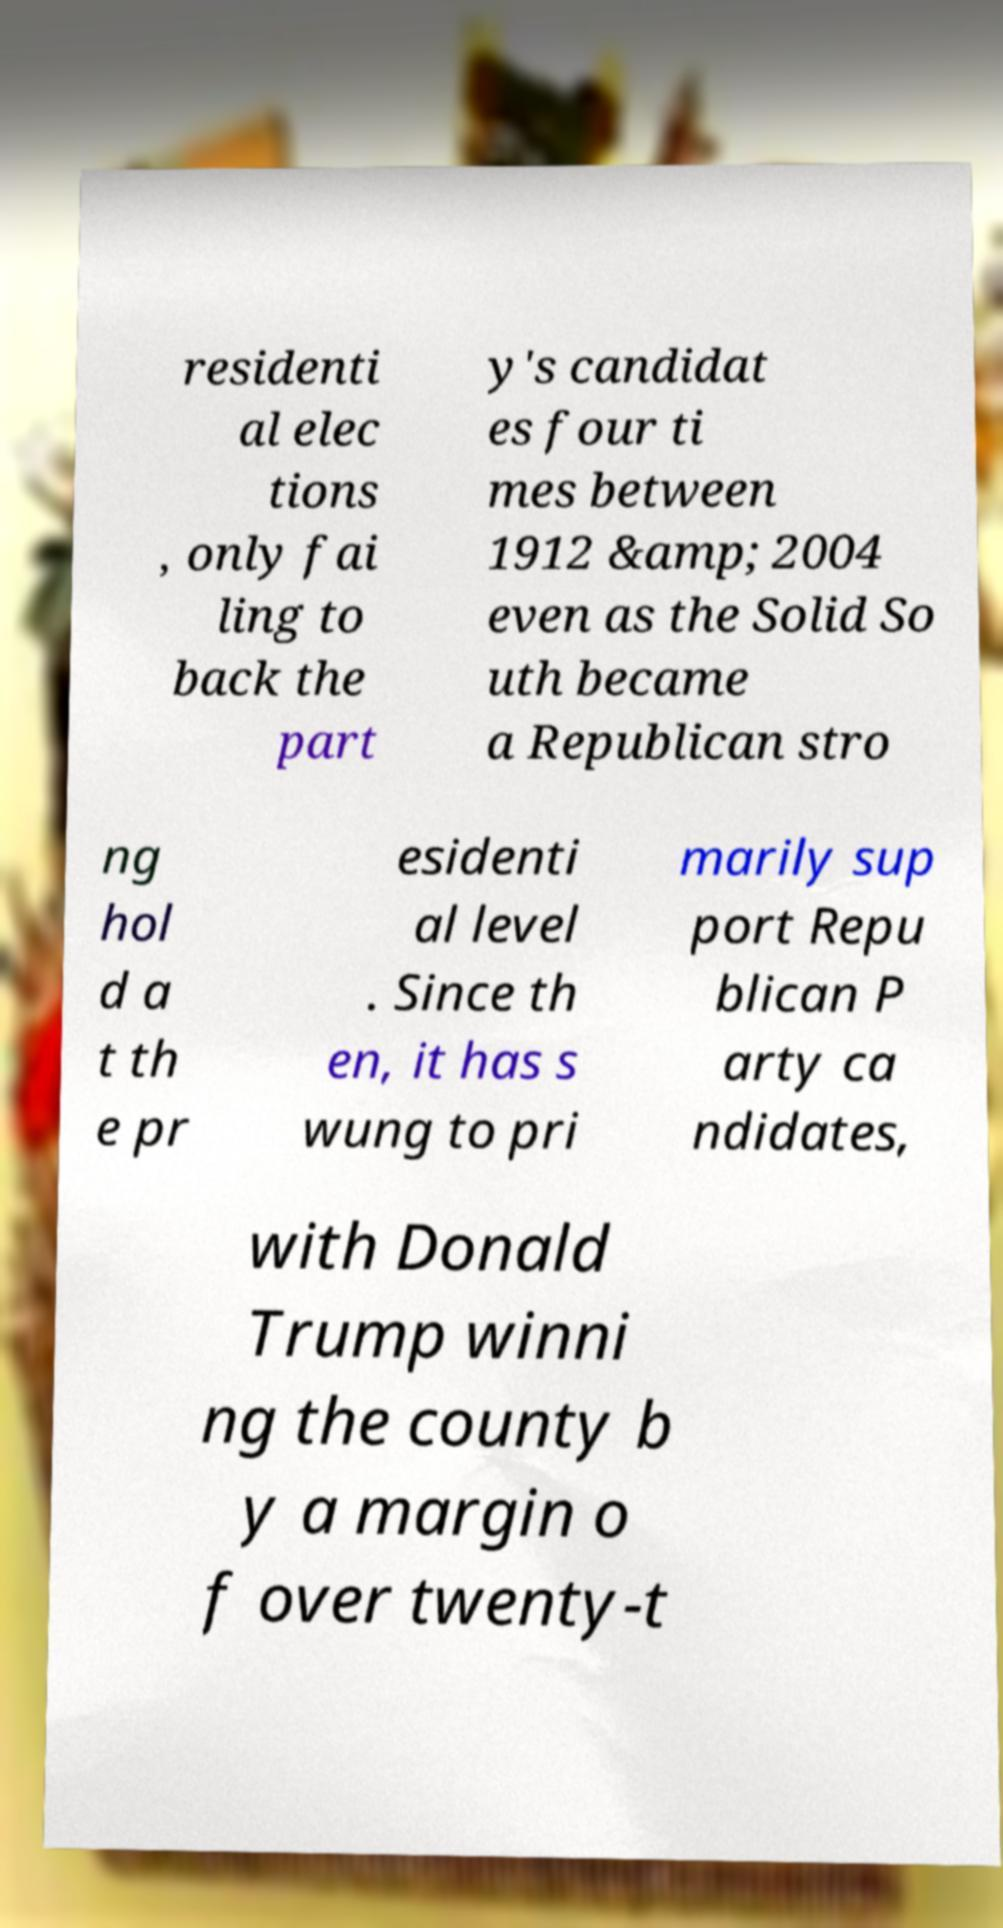Can you read and provide the text displayed in the image?This photo seems to have some interesting text. Can you extract and type it out for me? residenti al elec tions , only fai ling to back the part y's candidat es four ti mes between 1912 &amp; 2004 even as the Solid So uth became a Republican stro ng hol d a t th e pr esidenti al level . Since th en, it has s wung to pri marily sup port Repu blican P arty ca ndidates, with Donald Trump winni ng the county b y a margin o f over twenty-t 